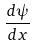Convert formula to latex. <formula><loc_0><loc_0><loc_500><loc_500>\frac { d \psi } { d x }</formula> 